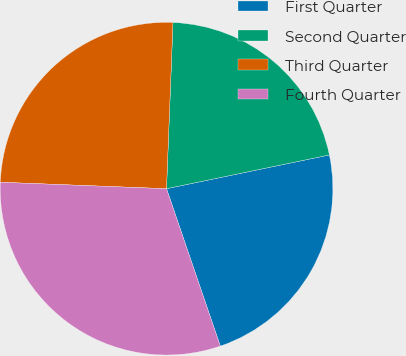Convert chart. <chart><loc_0><loc_0><loc_500><loc_500><pie_chart><fcel>First Quarter<fcel>Second Quarter<fcel>Third Quarter<fcel>Fourth Quarter<nl><fcel>23.01%<fcel>21.13%<fcel>25.0%<fcel>30.86%<nl></chart> 